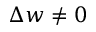<formula> <loc_0><loc_0><loc_500><loc_500>\Delta w \ne 0</formula> 